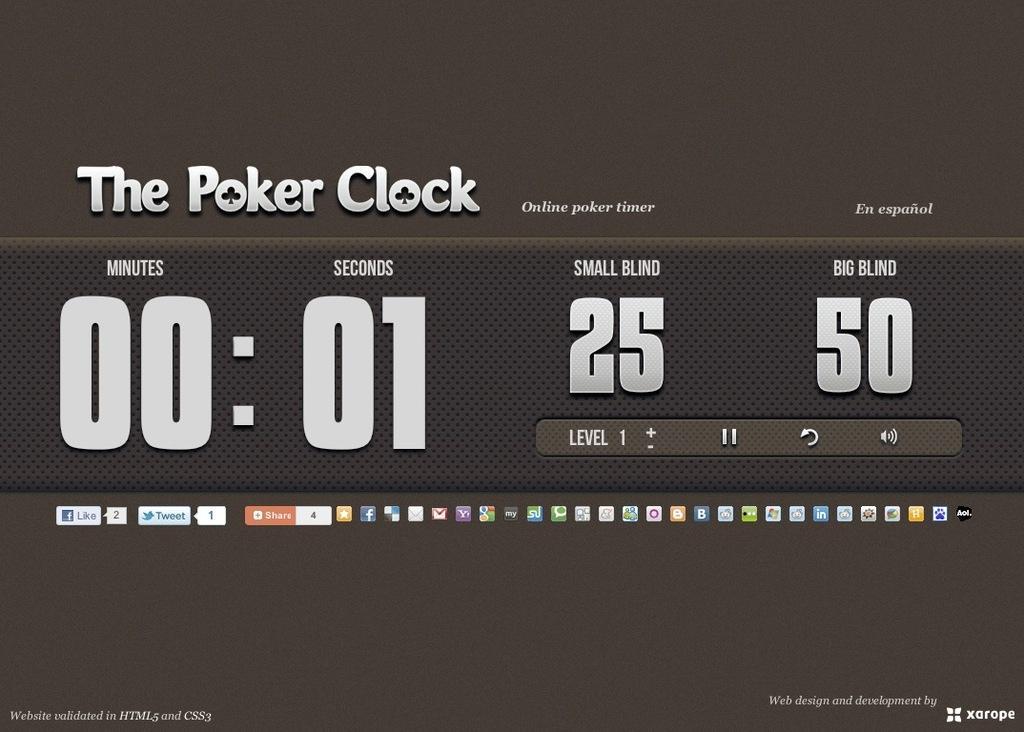Could you give a brief overview of what you see in this image? In this image in the center there is some text written on a board. 